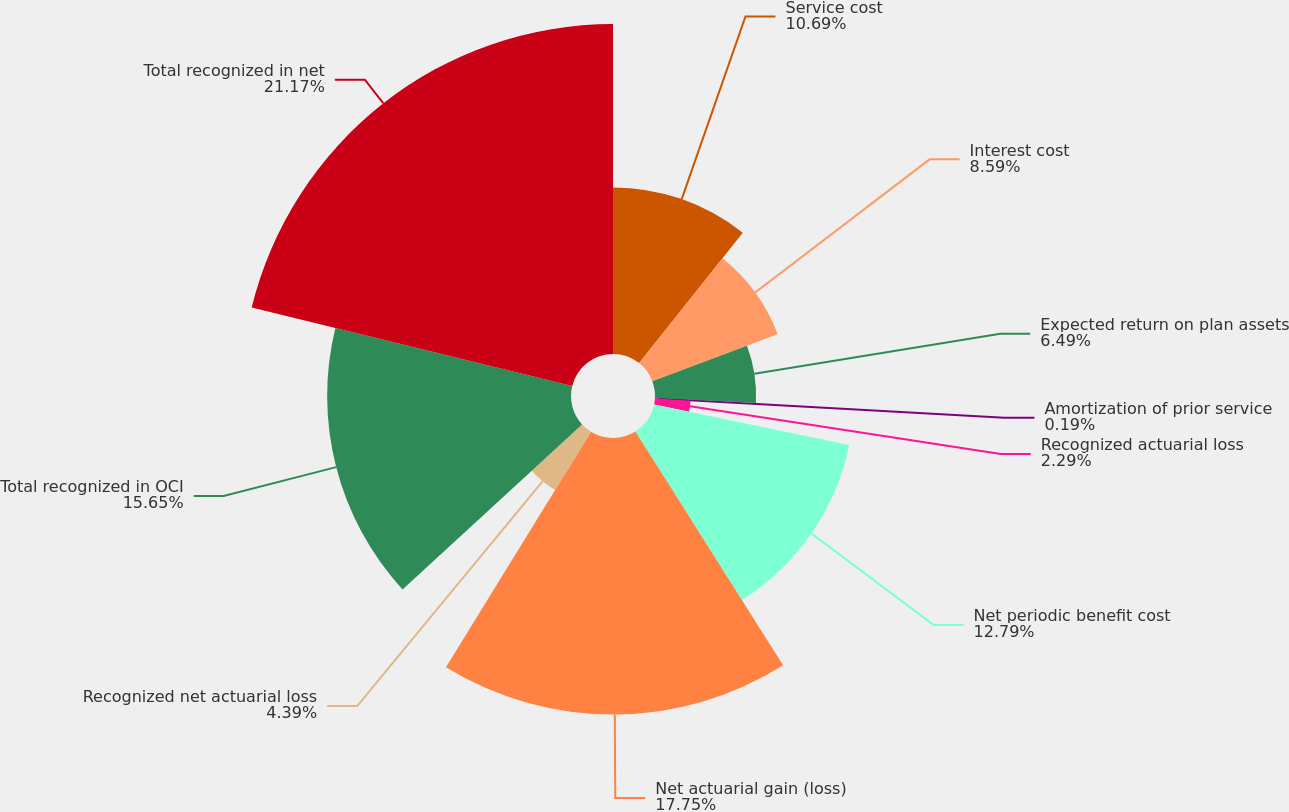<chart> <loc_0><loc_0><loc_500><loc_500><pie_chart><fcel>Service cost<fcel>Interest cost<fcel>Expected return on plan assets<fcel>Amortization of prior service<fcel>Recognized actuarial loss<fcel>Net periodic benefit cost<fcel>Net actuarial gain (loss)<fcel>Recognized net actuarial loss<fcel>Total recognized in OCI<fcel>Total recognized in net<nl><fcel>10.69%<fcel>8.59%<fcel>6.49%<fcel>0.19%<fcel>2.29%<fcel>12.79%<fcel>17.75%<fcel>4.39%<fcel>15.65%<fcel>21.18%<nl></chart> 